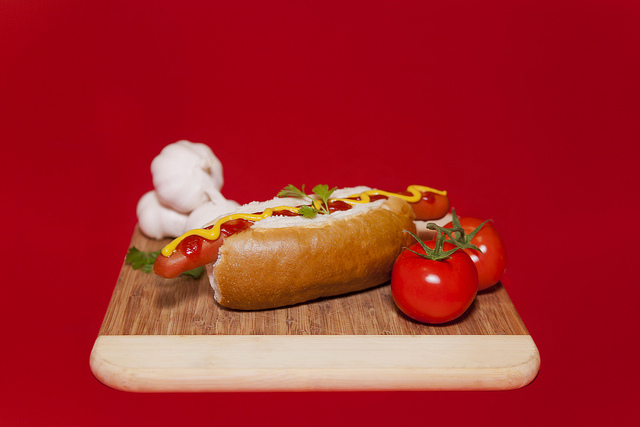Is this hot dog made out of cake? No, this hot dog is made from typical savory ingredients such as a bun and sausage, with ketchup and mustard as toppings. 